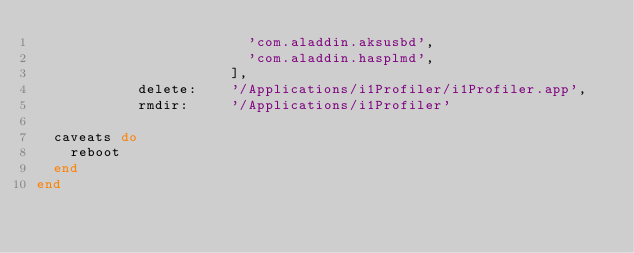Convert code to text. <code><loc_0><loc_0><loc_500><loc_500><_Ruby_>                         'com.aladdin.aksusbd',
                         'com.aladdin.hasplmd',
                       ],
            delete:    '/Applications/i1Profiler/i1Profiler.app',
            rmdir:     '/Applications/i1Profiler'

  caveats do
    reboot
  end
end
</code> 